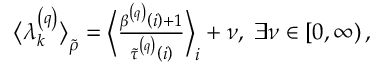Convert formula to latex. <formula><loc_0><loc_0><loc_500><loc_500>\begin{array} { r } { \left \langle \lambda _ { k } ^ { \left ( q \right ) } \right \rangle _ { \widetilde { \rho } } = \left \langle \frac { \beta ^ { \left ( q \right ) } \left ( i \right ) + 1 } { \widetilde { \tau } ^ { \left ( q \right ) } \left ( i \right ) } \right \rangle _ { i } + \nu , \, \exists \nu \in \left [ 0 , \infty \right ) , } \end{array}</formula> 